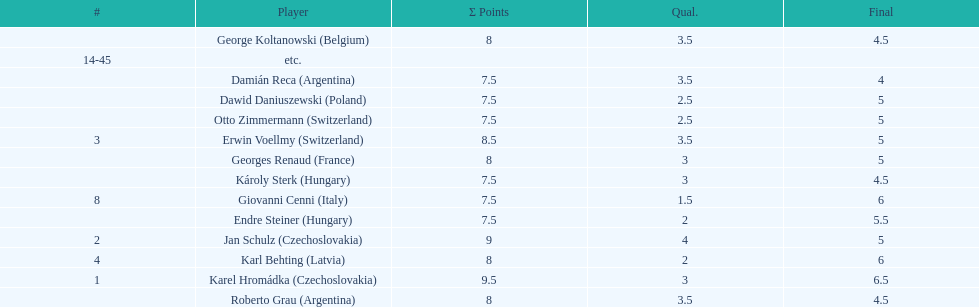Jan schulz is ranked immediately below which player? Karel Hromádka. 